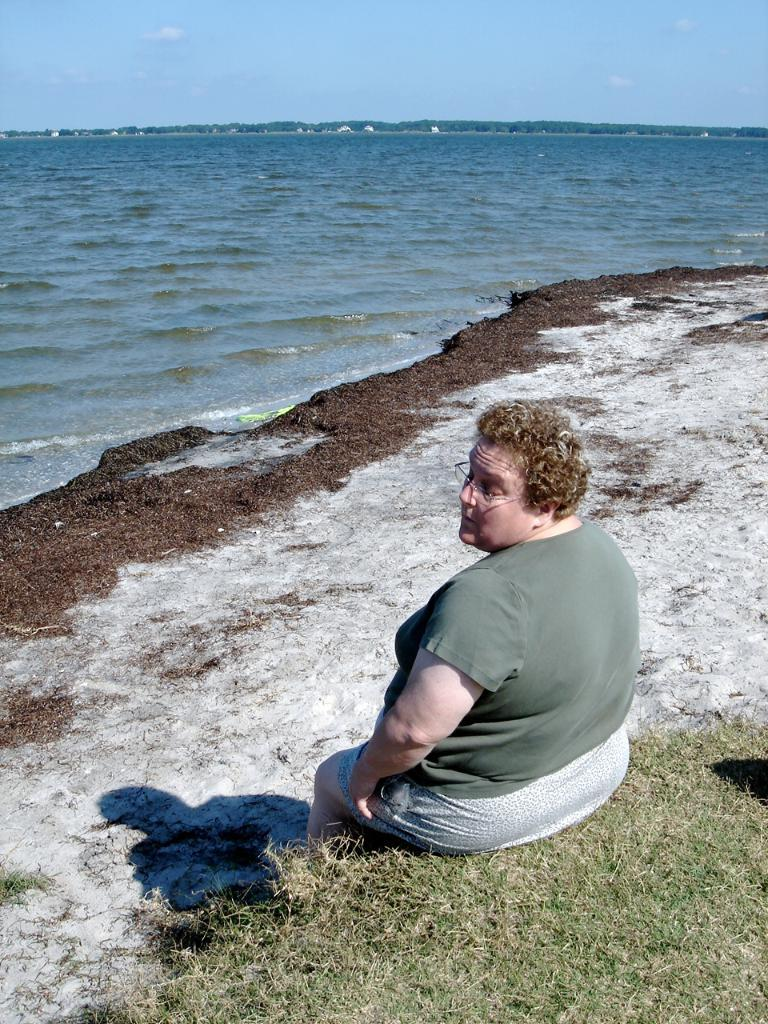What is the person in the image doing? The person is sitting on the grass. What can be seen in the background of the image? The background of the image includes water. What is visible in the sky in the image? There are clouds visible in the sky. What type of plantation can be seen in the image? There is no plantation present in the image. Is there a scarecrow visible in the image? There is no scarecrow present in the image. 